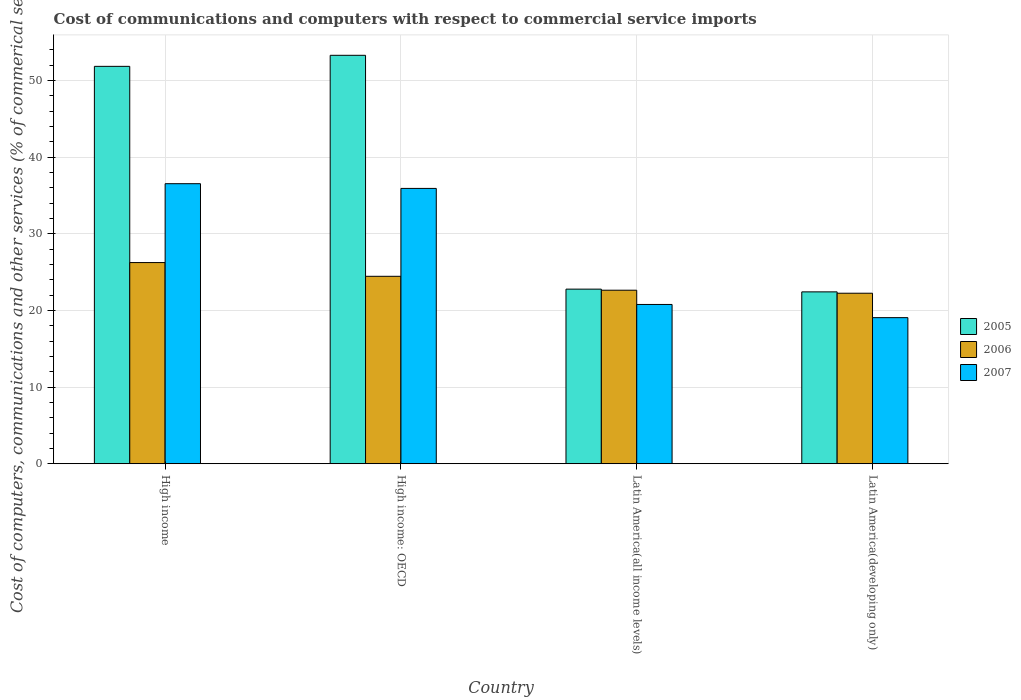How many different coloured bars are there?
Keep it short and to the point. 3. How many groups of bars are there?
Offer a very short reply. 4. Are the number of bars per tick equal to the number of legend labels?
Provide a succinct answer. Yes. How many bars are there on the 4th tick from the left?
Your response must be concise. 3. How many bars are there on the 1st tick from the right?
Your response must be concise. 3. What is the label of the 1st group of bars from the left?
Your answer should be compact. High income. In how many cases, is the number of bars for a given country not equal to the number of legend labels?
Provide a short and direct response. 0. What is the cost of communications and computers in 2007 in Latin America(all income levels)?
Your response must be concise. 20.77. Across all countries, what is the maximum cost of communications and computers in 2006?
Your response must be concise. 26.24. Across all countries, what is the minimum cost of communications and computers in 2006?
Offer a terse response. 22.24. In which country was the cost of communications and computers in 2005 minimum?
Keep it short and to the point. Latin America(developing only). What is the total cost of communications and computers in 2005 in the graph?
Offer a very short reply. 150.29. What is the difference between the cost of communications and computers in 2007 in High income and that in High income: OECD?
Your answer should be compact. 0.61. What is the difference between the cost of communications and computers in 2007 in Latin America(all income levels) and the cost of communications and computers in 2005 in Latin America(developing only)?
Give a very brief answer. -1.64. What is the average cost of communications and computers in 2007 per country?
Offer a very short reply. 28.07. What is the difference between the cost of communications and computers of/in 2005 and cost of communications and computers of/in 2007 in High income?
Provide a short and direct response. 15.31. What is the ratio of the cost of communications and computers in 2007 in High income: OECD to that in Latin America(all income levels)?
Offer a very short reply. 1.73. Is the difference between the cost of communications and computers in 2005 in High income and Latin America(all income levels) greater than the difference between the cost of communications and computers in 2007 in High income and Latin America(all income levels)?
Give a very brief answer. Yes. What is the difference between the highest and the second highest cost of communications and computers in 2005?
Give a very brief answer. -1.44. What is the difference between the highest and the lowest cost of communications and computers in 2005?
Give a very brief answer. 30.86. In how many countries, is the cost of communications and computers in 2005 greater than the average cost of communications and computers in 2005 taken over all countries?
Provide a succinct answer. 2. Is it the case that in every country, the sum of the cost of communications and computers in 2006 and cost of communications and computers in 2007 is greater than the cost of communications and computers in 2005?
Offer a terse response. Yes. Are all the bars in the graph horizontal?
Provide a succinct answer. No. Are the values on the major ticks of Y-axis written in scientific E-notation?
Ensure brevity in your answer.  No. Does the graph contain grids?
Keep it short and to the point. Yes. Where does the legend appear in the graph?
Keep it short and to the point. Center right. How many legend labels are there?
Make the answer very short. 3. How are the legend labels stacked?
Your answer should be very brief. Vertical. What is the title of the graph?
Your response must be concise. Cost of communications and computers with respect to commercial service imports. Does "1962" appear as one of the legend labels in the graph?
Provide a succinct answer. No. What is the label or title of the X-axis?
Offer a terse response. Country. What is the label or title of the Y-axis?
Your answer should be compact. Cost of computers, communications and other services (% of commerical service exports). What is the Cost of computers, communications and other services (% of commerical service exports) in 2005 in High income?
Make the answer very short. 51.83. What is the Cost of computers, communications and other services (% of commerical service exports) of 2006 in High income?
Provide a short and direct response. 26.24. What is the Cost of computers, communications and other services (% of commerical service exports) of 2007 in High income?
Offer a terse response. 36.52. What is the Cost of computers, communications and other services (% of commerical service exports) of 2005 in High income: OECD?
Provide a succinct answer. 53.27. What is the Cost of computers, communications and other services (% of commerical service exports) of 2006 in High income: OECD?
Your answer should be compact. 24.45. What is the Cost of computers, communications and other services (% of commerical service exports) in 2007 in High income: OECD?
Your answer should be very brief. 35.91. What is the Cost of computers, communications and other services (% of commerical service exports) in 2005 in Latin America(all income levels)?
Ensure brevity in your answer.  22.77. What is the Cost of computers, communications and other services (% of commerical service exports) in 2006 in Latin America(all income levels)?
Ensure brevity in your answer.  22.63. What is the Cost of computers, communications and other services (% of commerical service exports) in 2007 in Latin America(all income levels)?
Provide a succinct answer. 20.77. What is the Cost of computers, communications and other services (% of commerical service exports) of 2005 in Latin America(developing only)?
Offer a terse response. 22.42. What is the Cost of computers, communications and other services (% of commerical service exports) of 2006 in Latin America(developing only)?
Your answer should be compact. 22.24. What is the Cost of computers, communications and other services (% of commerical service exports) of 2007 in Latin America(developing only)?
Your response must be concise. 19.05. Across all countries, what is the maximum Cost of computers, communications and other services (% of commerical service exports) in 2005?
Provide a succinct answer. 53.27. Across all countries, what is the maximum Cost of computers, communications and other services (% of commerical service exports) of 2006?
Keep it short and to the point. 26.24. Across all countries, what is the maximum Cost of computers, communications and other services (% of commerical service exports) in 2007?
Ensure brevity in your answer.  36.52. Across all countries, what is the minimum Cost of computers, communications and other services (% of commerical service exports) in 2005?
Offer a very short reply. 22.42. Across all countries, what is the minimum Cost of computers, communications and other services (% of commerical service exports) in 2006?
Your answer should be very brief. 22.24. Across all countries, what is the minimum Cost of computers, communications and other services (% of commerical service exports) in 2007?
Make the answer very short. 19.05. What is the total Cost of computers, communications and other services (% of commerical service exports) in 2005 in the graph?
Your answer should be very brief. 150.29. What is the total Cost of computers, communications and other services (% of commerical service exports) of 2006 in the graph?
Offer a terse response. 95.56. What is the total Cost of computers, communications and other services (% of commerical service exports) of 2007 in the graph?
Give a very brief answer. 112.26. What is the difference between the Cost of computers, communications and other services (% of commerical service exports) of 2005 in High income and that in High income: OECD?
Offer a terse response. -1.44. What is the difference between the Cost of computers, communications and other services (% of commerical service exports) of 2006 in High income and that in High income: OECD?
Give a very brief answer. 1.79. What is the difference between the Cost of computers, communications and other services (% of commerical service exports) in 2007 in High income and that in High income: OECD?
Ensure brevity in your answer.  0.61. What is the difference between the Cost of computers, communications and other services (% of commerical service exports) of 2005 in High income and that in Latin America(all income levels)?
Keep it short and to the point. 29.06. What is the difference between the Cost of computers, communications and other services (% of commerical service exports) of 2006 in High income and that in Latin America(all income levels)?
Offer a very short reply. 3.61. What is the difference between the Cost of computers, communications and other services (% of commerical service exports) of 2007 in High income and that in Latin America(all income levels)?
Provide a succinct answer. 15.75. What is the difference between the Cost of computers, communications and other services (% of commerical service exports) in 2005 in High income and that in Latin America(developing only)?
Ensure brevity in your answer.  29.41. What is the difference between the Cost of computers, communications and other services (% of commerical service exports) in 2006 in High income and that in Latin America(developing only)?
Provide a short and direct response. 4. What is the difference between the Cost of computers, communications and other services (% of commerical service exports) in 2007 in High income and that in Latin America(developing only)?
Make the answer very short. 17.47. What is the difference between the Cost of computers, communications and other services (% of commerical service exports) of 2005 in High income: OECD and that in Latin America(all income levels)?
Make the answer very short. 30.5. What is the difference between the Cost of computers, communications and other services (% of commerical service exports) in 2006 in High income: OECD and that in Latin America(all income levels)?
Give a very brief answer. 1.81. What is the difference between the Cost of computers, communications and other services (% of commerical service exports) of 2007 in High income: OECD and that in Latin America(all income levels)?
Your response must be concise. 15.14. What is the difference between the Cost of computers, communications and other services (% of commerical service exports) of 2005 in High income: OECD and that in Latin America(developing only)?
Your answer should be compact. 30.86. What is the difference between the Cost of computers, communications and other services (% of commerical service exports) of 2006 in High income: OECD and that in Latin America(developing only)?
Offer a very short reply. 2.21. What is the difference between the Cost of computers, communications and other services (% of commerical service exports) of 2007 in High income: OECD and that in Latin America(developing only)?
Offer a very short reply. 16.85. What is the difference between the Cost of computers, communications and other services (% of commerical service exports) in 2005 in Latin America(all income levels) and that in Latin America(developing only)?
Ensure brevity in your answer.  0.36. What is the difference between the Cost of computers, communications and other services (% of commerical service exports) in 2006 in Latin America(all income levels) and that in Latin America(developing only)?
Your answer should be very brief. 0.39. What is the difference between the Cost of computers, communications and other services (% of commerical service exports) of 2007 in Latin America(all income levels) and that in Latin America(developing only)?
Make the answer very short. 1.72. What is the difference between the Cost of computers, communications and other services (% of commerical service exports) of 2005 in High income and the Cost of computers, communications and other services (% of commerical service exports) of 2006 in High income: OECD?
Keep it short and to the point. 27.38. What is the difference between the Cost of computers, communications and other services (% of commerical service exports) of 2005 in High income and the Cost of computers, communications and other services (% of commerical service exports) of 2007 in High income: OECD?
Provide a short and direct response. 15.92. What is the difference between the Cost of computers, communications and other services (% of commerical service exports) of 2006 in High income and the Cost of computers, communications and other services (% of commerical service exports) of 2007 in High income: OECD?
Your answer should be very brief. -9.67. What is the difference between the Cost of computers, communications and other services (% of commerical service exports) in 2005 in High income and the Cost of computers, communications and other services (% of commerical service exports) in 2006 in Latin America(all income levels)?
Your answer should be very brief. 29.2. What is the difference between the Cost of computers, communications and other services (% of commerical service exports) in 2005 in High income and the Cost of computers, communications and other services (% of commerical service exports) in 2007 in Latin America(all income levels)?
Offer a very short reply. 31.06. What is the difference between the Cost of computers, communications and other services (% of commerical service exports) of 2006 in High income and the Cost of computers, communications and other services (% of commerical service exports) of 2007 in Latin America(all income levels)?
Make the answer very short. 5.46. What is the difference between the Cost of computers, communications and other services (% of commerical service exports) of 2005 in High income and the Cost of computers, communications and other services (% of commerical service exports) of 2006 in Latin America(developing only)?
Offer a terse response. 29.59. What is the difference between the Cost of computers, communications and other services (% of commerical service exports) of 2005 in High income and the Cost of computers, communications and other services (% of commerical service exports) of 2007 in Latin America(developing only)?
Make the answer very short. 32.78. What is the difference between the Cost of computers, communications and other services (% of commerical service exports) in 2006 in High income and the Cost of computers, communications and other services (% of commerical service exports) in 2007 in Latin America(developing only)?
Make the answer very short. 7.18. What is the difference between the Cost of computers, communications and other services (% of commerical service exports) of 2005 in High income: OECD and the Cost of computers, communications and other services (% of commerical service exports) of 2006 in Latin America(all income levels)?
Your answer should be compact. 30.64. What is the difference between the Cost of computers, communications and other services (% of commerical service exports) in 2005 in High income: OECD and the Cost of computers, communications and other services (% of commerical service exports) in 2007 in Latin America(all income levels)?
Your answer should be very brief. 32.5. What is the difference between the Cost of computers, communications and other services (% of commerical service exports) in 2006 in High income: OECD and the Cost of computers, communications and other services (% of commerical service exports) in 2007 in Latin America(all income levels)?
Your answer should be very brief. 3.67. What is the difference between the Cost of computers, communications and other services (% of commerical service exports) of 2005 in High income: OECD and the Cost of computers, communications and other services (% of commerical service exports) of 2006 in Latin America(developing only)?
Make the answer very short. 31.03. What is the difference between the Cost of computers, communications and other services (% of commerical service exports) in 2005 in High income: OECD and the Cost of computers, communications and other services (% of commerical service exports) in 2007 in Latin America(developing only)?
Make the answer very short. 34.22. What is the difference between the Cost of computers, communications and other services (% of commerical service exports) of 2006 in High income: OECD and the Cost of computers, communications and other services (% of commerical service exports) of 2007 in Latin America(developing only)?
Ensure brevity in your answer.  5.39. What is the difference between the Cost of computers, communications and other services (% of commerical service exports) in 2005 in Latin America(all income levels) and the Cost of computers, communications and other services (% of commerical service exports) in 2006 in Latin America(developing only)?
Make the answer very short. 0.53. What is the difference between the Cost of computers, communications and other services (% of commerical service exports) in 2005 in Latin America(all income levels) and the Cost of computers, communications and other services (% of commerical service exports) in 2007 in Latin America(developing only)?
Your response must be concise. 3.72. What is the difference between the Cost of computers, communications and other services (% of commerical service exports) in 2006 in Latin America(all income levels) and the Cost of computers, communications and other services (% of commerical service exports) in 2007 in Latin America(developing only)?
Offer a terse response. 3.58. What is the average Cost of computers, communications and other services (% of commerical service exports) in 2005 per country?
Offer a terse response. 37.57. What is the average Cost of computers, communications and other services (% of commerical service exports) in 2006 per country?
Keep it short and to the point. 23.89. What is the average Cost of computers, communications and other services (% of commerical service exports) in 2007 per country?
Offer a terse response. 28.07. What is the difference between the Cost of computers, communications and other services (% of commerical service exports) in 2005 and Cost of computers, communications and other services (% of commerical service exports) in 2006 in High income?
Provide a succinct answer. 25.59. What is the difference between the Cost of computers, communications and other services (% of commerical service exports) in 2005 and Cost of computers, communications and other services (% of commerical service exports) in 2007 in High income?
Your answer should be compact. 15.31. What is the difference between the Cost of computers, communications and other services (% of commerical service exports) in 2006 and Cost of computers, communications and other services (% of commerical service exports) in 2007 in High income?
Offer a terse response. -10.29. What is the difference between the Cost of computers, communications and other services (% of commerical service exports) in 2005 and Cost of computers, communications and other services (% of commerical service exports) in 2006 in High income: OECD?
Ensure brevity in your answer.  28.83. What is the difference between the Cost of computers, communications and other services (% of commerical service exports) in 2005 and Cost of computers, communications and other services (% of commerical service exports) in 2007 in High income: OECD?
Offer a terse response. 17.36. What is the difference between the Cost of computers, communications and other services (% of commerical service exports) in 2006 and Cost of computers, communications and other services (% of commerical service exports) in 2007 in High income: OECD?
Your answer should be compact. -11.46. What is the difference between the Cost of computers, communications and other services (% of commerical service exports) of 2005 and Cost of computers, communications and other services (% of commerical service exports) of 2006 in Latin America(all income levels)?
Keep it short and to the point. 0.14. What is the difference between the Cost of computers, communications and other services (% of commerical service exports) of 2005 and Cost of computers, communications and other services (% of commerical service exports) of 2007 in Latin America(all income levels)?
Provide a succinct answer. 2. What is the difference between the Cost of computers, communications and other services (% of commerical service exports) of 2006 and Cost of computers, communications and other services (% of commerical service exports) of 2007 in Latin America(all income levels)?
Your response must be concise. 1.86. What is the difference between the Cost of computers, communications and other services (% of commerical service exports) of 2005 and Cost of computers, communications and other services (% of commerical service exports) of 2006 in Latin America(developing only)?
Offer a terse response. 0.18. What is the difference between the Cost of computers, communications and other services (% of commerical service exports) of 2005 and Cost of computers, communications and other services (% of commerical service exports) of 2007 in Latin America(developing only)?
Your answer should be very brief. 3.36. What is the difference between the Cost of computers, communications and other services (% of commerical service exports) of 2006 and Cost of computers, communications and other services (% of commerical service exports) of 2007 in Latin America(developing only)?
Offer a terse response. 3.18. What is the ratio of the Cost of computers, communications and other services (% of commerical service exports) of 2005 in High income to that in High income: OECD?
Provide a succinct answer. 0.97. What is the ratio of the Cost of computers, communications and other services (% of commerical service exports) of 2006 in High income to that in High income: OECD?
Ensure brevity in your answer.  1.07. What is the ratio of the Cost of computers, communications and other services (% of commerical service exports) in 2007 in High income to that in High income: OECD?
Give a very brief answer. 1.02. What is the ratio of the Cost of computers, communications and other services (% of commerical service exports) in 2005 in High income to that in Latin America(all income levels)?
Your response must be concise. 2.28. What is the ratio of the Cost of computers, communications and other services (% of commerical service exports) of 2006 in High income to that in Latin America(all income levels)?
Your answer should be compact. 1.16. What is the ratio of the Cost of computers, communications and other services (% of commerical service exports) of 2007 in High income to that in Latin America(all income levels)?
Offer a terse response. 1.76. What is the ratio of the Cost of computers, communications and other services (% of commerical service exports) of 2005 in High income to that in Latin America(developing only)?
Keep it short and to the point. 2.31. What is the ratio of the Cost of computers, communications and other services (% of commerical service exports) of 2006 in High income to that in Latin America(developing only)?
Provide a short and direct response. 1.18. What is the ratio of the Cost of computers, communications and other services (% of commerical service exports) of 2007 in High income to that in Latin America(developing only)?
Your response must be concise. 1.92. What is the ratio of the Cost of computers, communications and other services (% of commerical service exports) in 2005 in High income: OECD to that in Latin America(all income levels)?
Offer a terse response. 2.34. What is the ratio of the Cost of computers, communications and other services (% of commerical service exports) of 2006 in High income: OECD to that in Latin America(all income levels)?
Offer a terse response. 1.08. What is the ratio of the Cost of computers, communications and other services (% of commerical service exports) of 2007 in High income: OECD to that in Latin America(all income levels)?
Ensure brevity in your answer.  1.73. What is the ratio of the Cost of computers, communications and other services (% of commerical service exports) of 2005 in High income: OECD to that in Latin America(developing only)?
Ensure brevity in your answer.  2.38. What is the ratio of the Cost of computers, communications and other services (% of commerical service exports) in 2006 in High income: OECD to that in Latin America(developing only)?
Your response must be concise. 1.1. What is the ratio of the Cost of computers, communications and other services (% of commerical service exports) in 2007 in High income: OECD to that in Latin America(developing only)?
Provide a short and direct response. 1.88. What is the ratio of the Cost of computers, communications and other services (% of commerical service exports) in 2005 in Latin America(all income levels) to that in Latin America(developing only)?
Give a very brief answer. 1.02. What is the ratio of the Cost of computers, communications and other services (% of commerical service exports) in 2006 in Latin America(all income levels) to that in Latin America(developing only)?
Make the answer very short. 1.02. What is the ratio of the Cost of computers, communications and other services (% of commerical service exports) of 2007 in Latin America(all income levels) to that in Latin America(developing only)?
Make the answer very short. 1.09. What is the difference between the highest and the second highest Cost of computers, communications and other services (% of commerical service exports) of 2005?
Give a very brief answer. 1.44. What is the difference between the highest and the second highest Cost of computers, communications and other services (% of commerical service exports) in 2006?
Offer a very short reply. 1.79. What is the difference between the highest and the second highest Cost of computers, communications and other services (% of commerical service exports) in 2007?
Your answer should be very brief. 0.61. What is the difference between the highest and the lowest Cost of computers, communications and other services (% of commerical service exports) of 2005?
Your answer should be very brief. 30.86. What is the difference between the highest and the lowest Cost of computers, communications and other services (% of commerical service exports) of 2006?
Your answer should be compact. 4. What is the difference between the highest and the lowest Cost of computers, communications and other services (% of commerical service exports) of 2007?
Give a very brief answer. 17.47. 